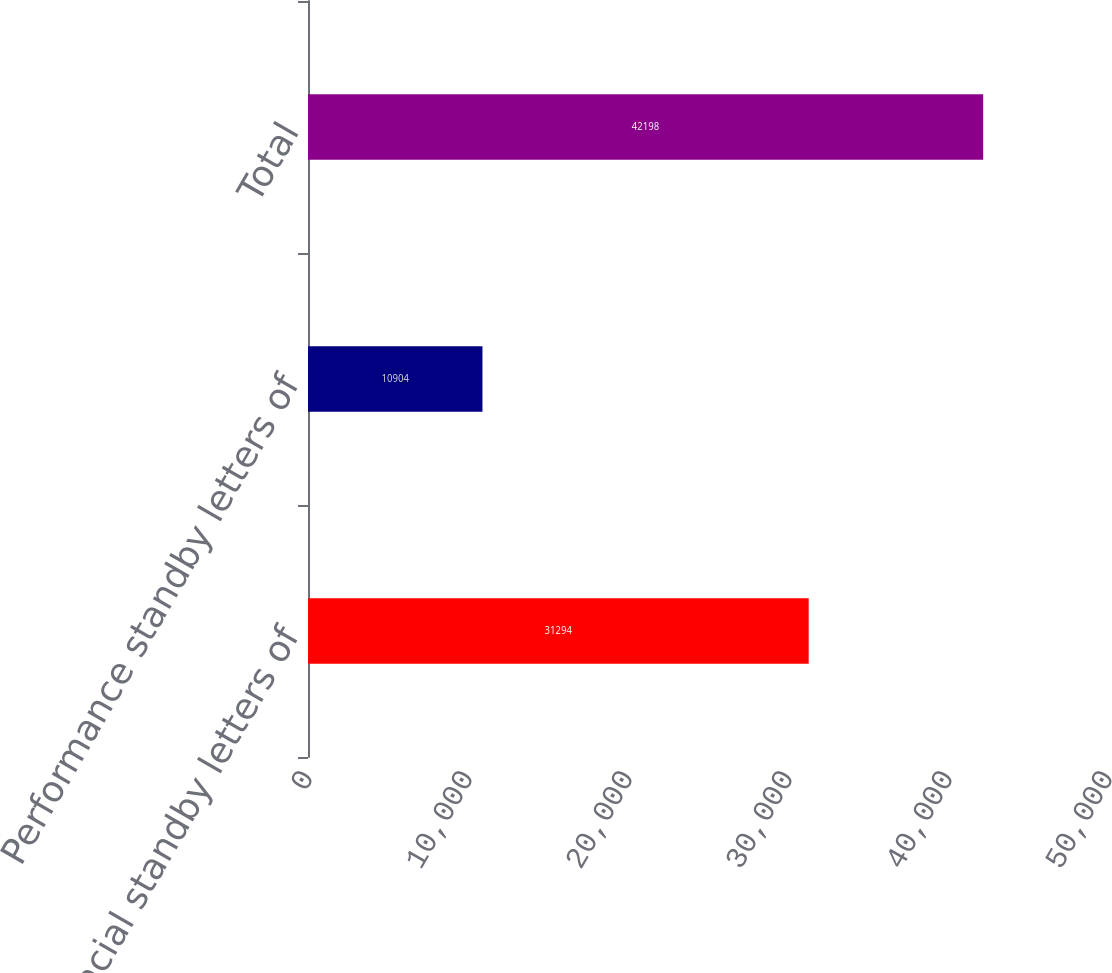<chart> <loc_0><loc_0><loc_500><loc_500><bar_chart><fcel>Financial standby letters of<fcel>Performance standby letters of<fcel>Total<nl><fcel>31294<fcel>10904<fcel>42198<nl></chart> 